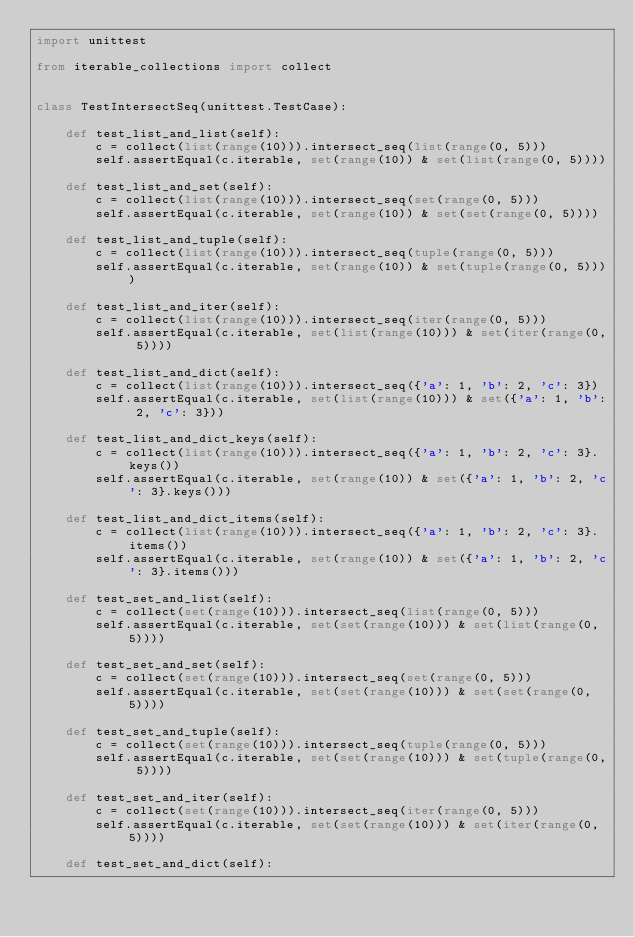Convert code to text. <code><loc_0><loc_0><loc_500><loc_500><_Python_>import unittest

from iterable_collections import collect


class TestIntersectSeq(unittest.TestCase):

    def test_list_and_list(self):
        c = collect(list(range(10))).intersect_seq(list(range(0, 5)))
        self.assertEqual(c.iterable, set(range(10)) & set(list(range(0, 5))))

    def test_list_and_set(self):
        c = collect(list(range(10))).intersect_seq(set(range(0, 5)))
        self.assertEqual(c.iterable, set(range(10)) & set(set(range(0, 5))))

    def test_list_and_tuple(self):
        c = collect(list(range(10))).intersect_seq(tuple(range(0, 5)))
        self.assertEqual(c.iterable, set(range(10)) & set(tuple(range(0, 5))))

    def test_list_and_iter(self):
        c = collect(list(range(10))).intersect_seq(iter(range(0, 5)))
        self.assertEqual(c.iterable, set(list(range(10))) & set(iter(range(0, 5))))

    def test_list_and_dict(self):
        c = collect(list(range(10))).intersect_seq({'a': 1, 'b': 2, 'c': 3})
        self.assertEqual(c.iterable, set(list(range(10))) & set({'a': 1, 'b': 2, 'c': 3}))

    def test_list_and_dict_keys(self):
        c = collect(list(range(10))).intersect_seq({'a': 1, 'b': 2, 'c': 3}.keys())
        self.assertEqual(c.iterable, set(range(10)) & set({'a': 1, 'b': 2, 'c': 3}.keys()))

    def test_list_and_dict_items(self):
        c = collect(list(range(10))).intersect_seq({'a': 1, 'b': 2, 'c': 3}.items())
        self.assertEqual(c.iterable, set(range(10)) & set({'a': 1, 'b': 2, 'c': 3}.items()))

    def test_set_and_list(self):
        c = collect(set(range(10))).intersect_seq(list(range(0, 5)))
        self.assertEqual(c.iterable, set(set(range(10))) & set(list(range(0, 5))))

    def test_set_and_set(self):
        c = collect(set(range(10))).intersect_seq(set(range(0, 5)))
        self.assertEqual(c.iterable, set(set(range(10))) & set(set(range(0, 5))))

    def test_set_and_tuple(self):
        c = collect(set(range(10))).intersect_seq(tuple(range(0, 5)))
        self.assertEqual(c.iterable, set(set(range(10))) & set(tuple(range(0, 5))))

    def test_set_and_iter(self):
        c = collect(set(range(10))).intersect_seq(iter(range(0, 5)))
        self.assertEqual(c.iterable, set(set(range(10))) & set(iter(range(0, 5))))

    def test_set_and_dict(self):</code> 